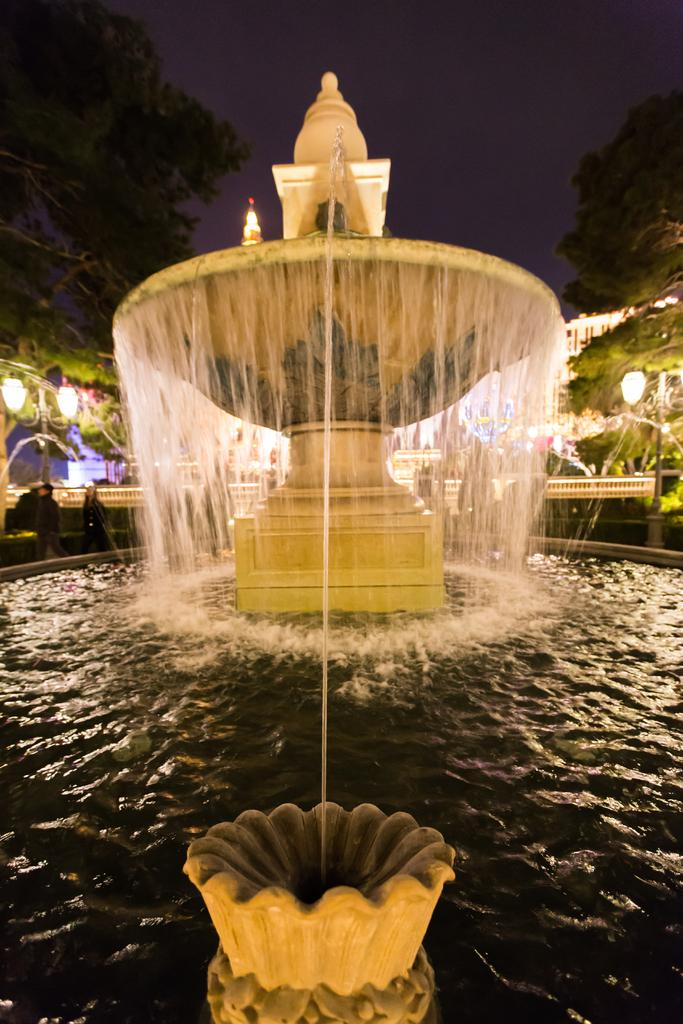What type of water feature is present in the image? There is a fountain with a waterfall in the image. What additional features are present near the fountain? There are poles with lights on either side of the fountain. What type of natural elements can be seen in the image? There are trees visible in the image. What is visible in the background of the image? There is a sky visible in the image. What type of oil is being used to power the fountain in the image? There is no indication in the image that the fountain is powered by oil, and therefore no such information can be provided. 